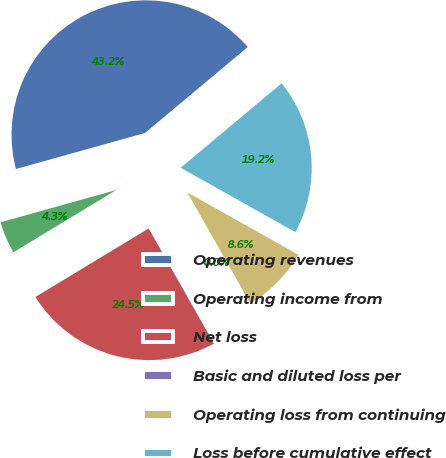Convert chart to OTSL. <chart><loc_0><loc_0><loc_500><loc_500><pie_chart><fcel>Operating revenues<fcel>Operating income from<fcel>Net loss<fcel>Basic and diluted loss per<fcel>Operating loss from continuing<fcel>Loss before cumulative effect<nl><fcel>43.25%<fcel>4.33%<fcel>24.54%<fcel>0.0%<fcel>8.65%<fcel>19.23%<nl></chart> 